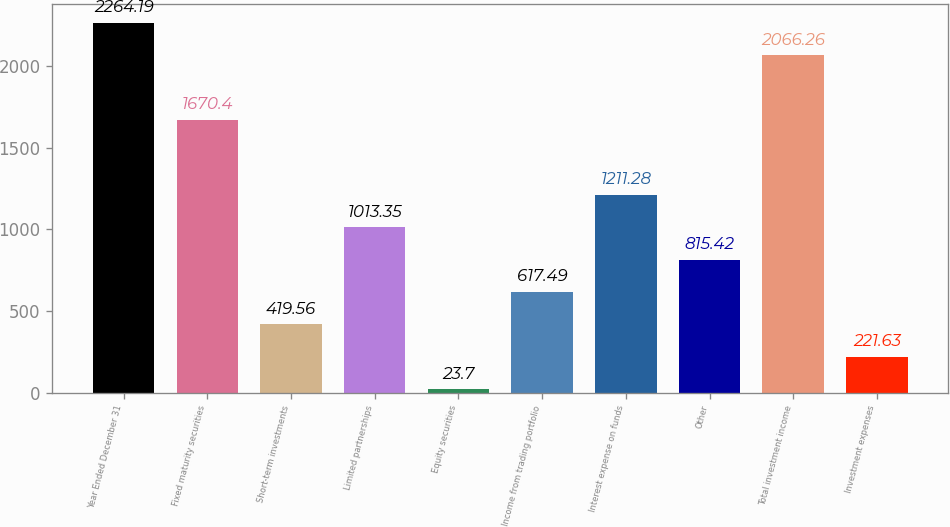Convert chart. <chart><loc_0><loc_0><loc_500><loc_500><bar_chart><fcel>Year Ended December 31<fcel>Fixed maturity securities<fcel>Short-term investments<fcel>Limited partnerships<fcel>Equity securities<fcel>Income from trading portfolio<fcel>Interest expense on funds<fcel>Other<fcel>Total investment income<fcel>Investment expenses<nl><fcel>2264.19<fcel>1670.4<fcel>419.56<fcel>1013.35<fcel>23.7<fcel>617.49<fcel>1211.28<fcel>815.42<fcel>2066.26<fcel>221.63<nl></chart> 